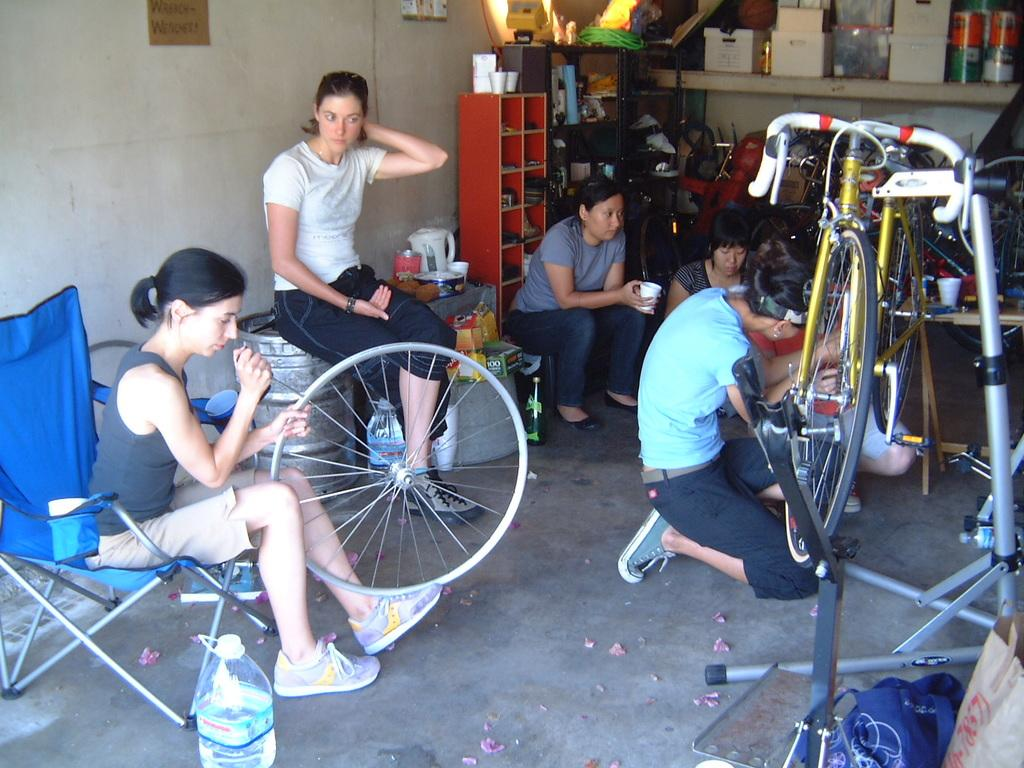Who is present in the bicycle shop in the image? There are women in the bicycle shop. What can be seen in the background of the image? There are shelves with instruments in the background. What is on the table in the image? There are objects on a table in the image. What type of hill can be seen in the background of the image? There is no hill visible in the image; it takes place in a bicycle shop with shelves and instruments in the background. 